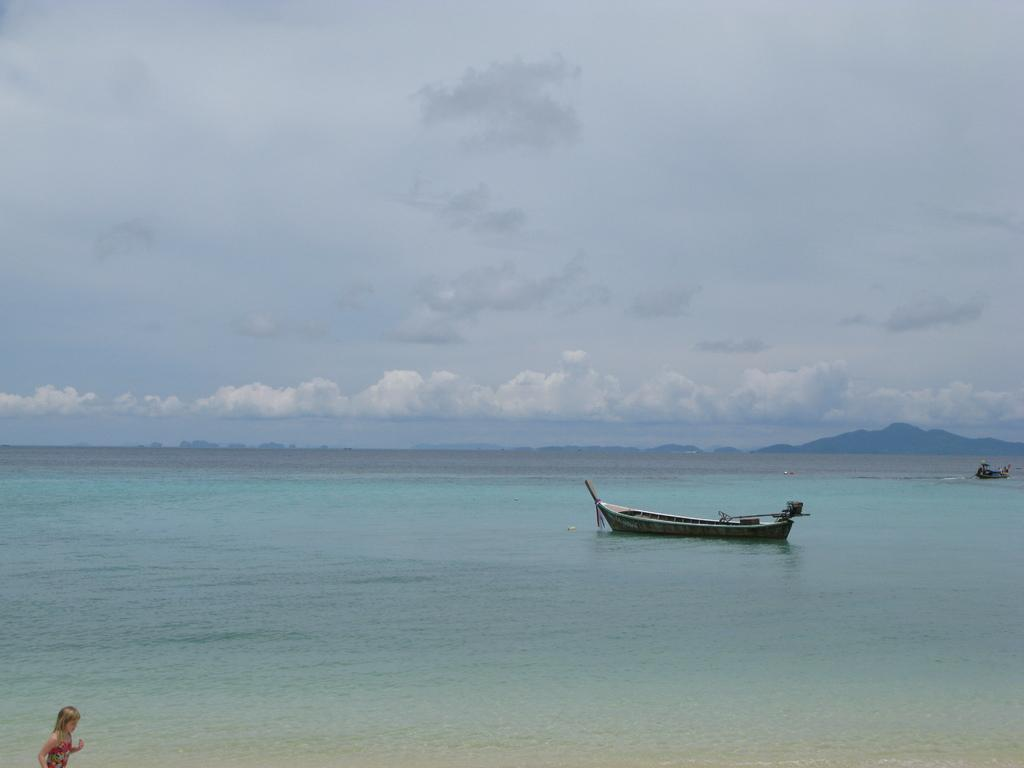What is in the water in the image? There is a boat in the water in the image. What colors can be seen in the sky in the background? The sky in the background is a combination of white and blue colors. Can you describe the person in the image? There is a person in the image, and they are wearing a red dress. What type of tank can be seen on the side of the boat in the image? There is no tank visible on the side of the boat in the image. What color is the sweater worn by the person in the image? The person in the image is not wearing a sweater; they are wearing a red dress. 